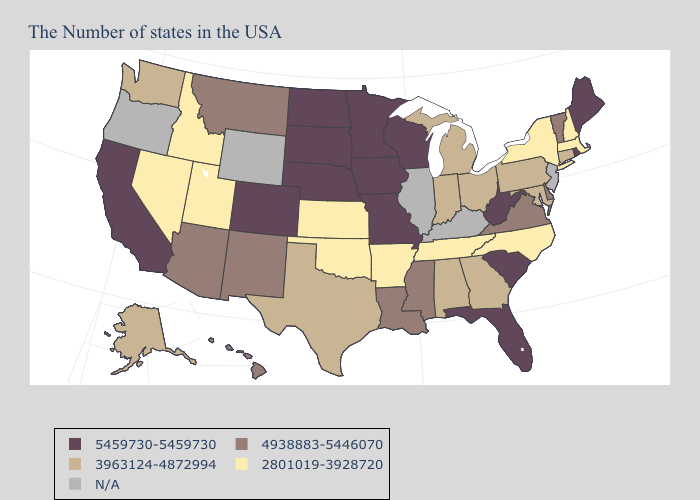Does the first symbol in the legend represent the smallest category?
Keep it brief. No. What is the value of Arizona?
Concise answer only. 4938883-5446070. What is the lowest value in the South?
Concise answer only. 2801019-3928720. Does the map have missing data?
Concise answer only. Yes. Name the states that have a value in the range N/A?
Concise answer only. New Jersey, Kentucky, Illinois, Wyoming, Oregon. What is the lowest value in the West?
Answer briefly. 2801019-3928720. Name the states that have a value in the range 5459730-5459730?
Keep it brief. Maine, Rhode Island, South Carolina, West Virginia, Florida, Wisconsin, Missouri, Minnesota, Iowa, Nebraska, South Dakota, North Dakota, Colorado, California. What is the value of Mississippi?
Be succinct. 4938883-5446070. Which states have the highest value in the USA?
Give a very brief answer. Maine, Rhode Island, South Carolina, West Virginia, Florida, Wisconsin, Missouri, Minnesota, Iowa, Nebraska, South Dakota, North Dakota, Colorado, California. Does Louisiana have the lowest value in the South?
Concise answer only. No. What is the highest value in the MidWest ?
Be succinct. 5459730-5459730. How many symbols are there in the legend?
Be succinct. 5. What is the lowest value in the MidWest?
Answer briefly. 2801019-3928720. What is the value of North Dakota?
Give a very brief answer. 5459730-5459730. Name the states that have a value in the range 4938883-5446070?
Keep it brief. Vermont, Delaware, Virginia, Mississippi, Louisiana, New Mexico, Montana, Arizona, Hawaii. 